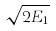Convert formula to latex. <formula><loc_0><loc_0><loc_500><loc_500>\sqrt { 2 E _ { 1 } }</formula> 